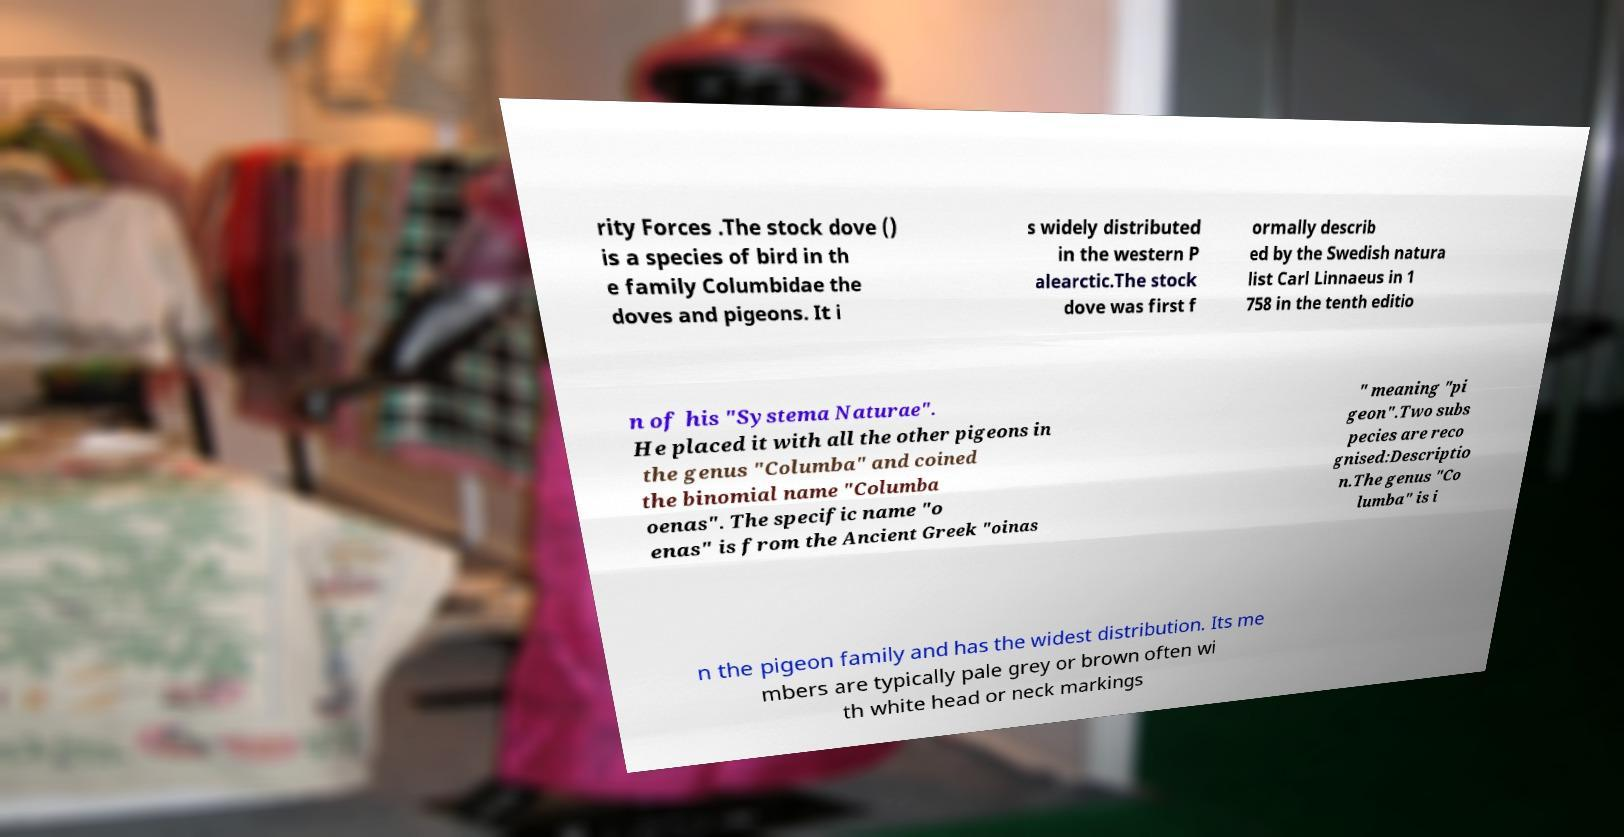Please identify and transcribe the text found in this image. rity Forces .The stock dove () is a species of bird in th e family Columbidae the doves and pigeons. It i s widely distributed in the western P alearctic.The stock dove was first f ormally describ ed by the Swedish natura list Carl Linnaeus in 1 758 in the tenth editio n of his "Systema Naturae". He placed it with all the other pigeons in the genus "Columba" and coined the binomial name "Columba oenas". The specific name "o enas" is from the Ancient Greek "oinas " meaning "pi geon".Two subs pecies are reco gnised:Descriptio n.The genus "Co lumba" is i n the pigeon family and has the widest distribution. Its me mbers are typically pale grey or brown often wi th white head or neck markings 